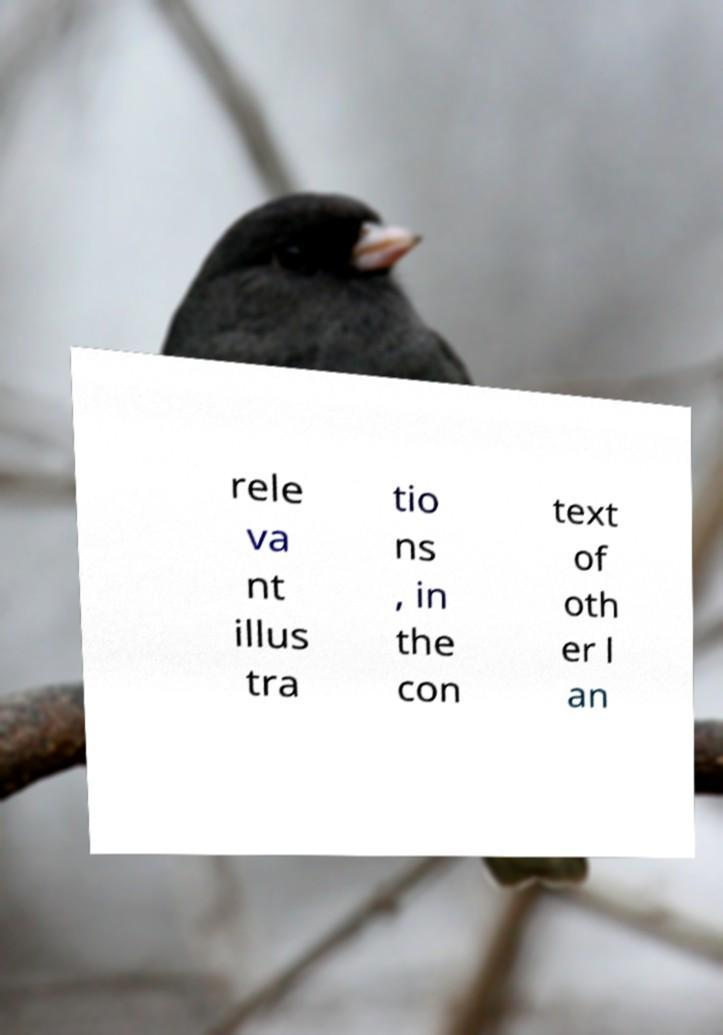There's text embedded in this image that I need extracted. Can you transcribe it verbatim? rele va nt illus tra tio ns , in the con text of oth er l an 